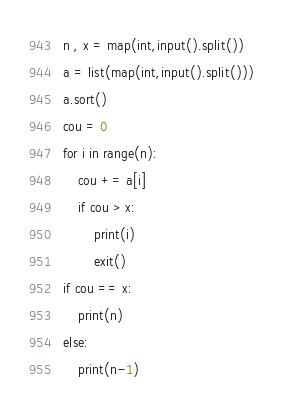<code> <loc_0><loc_0><loc_500><loc_500><_Python_>n , x = map(int,input().split())
a = list(map(int,input().split()))
a.sort()
cou = 0
for i in range(n):
    cou += a[i]
    if cou > x:
        print(i)
        exit()
if cou == x:
    print(n)
else:
    print(n-1)</code> 